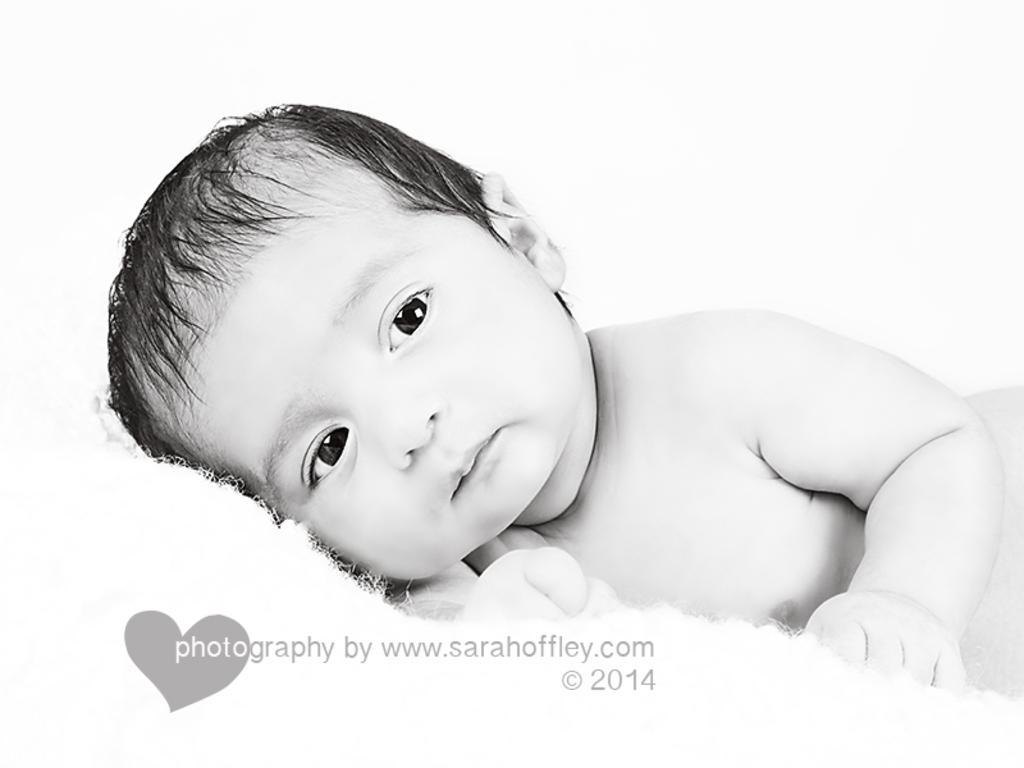Could you give a brief overview of what you see in this image? In this picture we can see a small baby boy is lying in the front and looking at the camera. Behind there is a white background and on the bottom side we can see a small watermark on the image. 